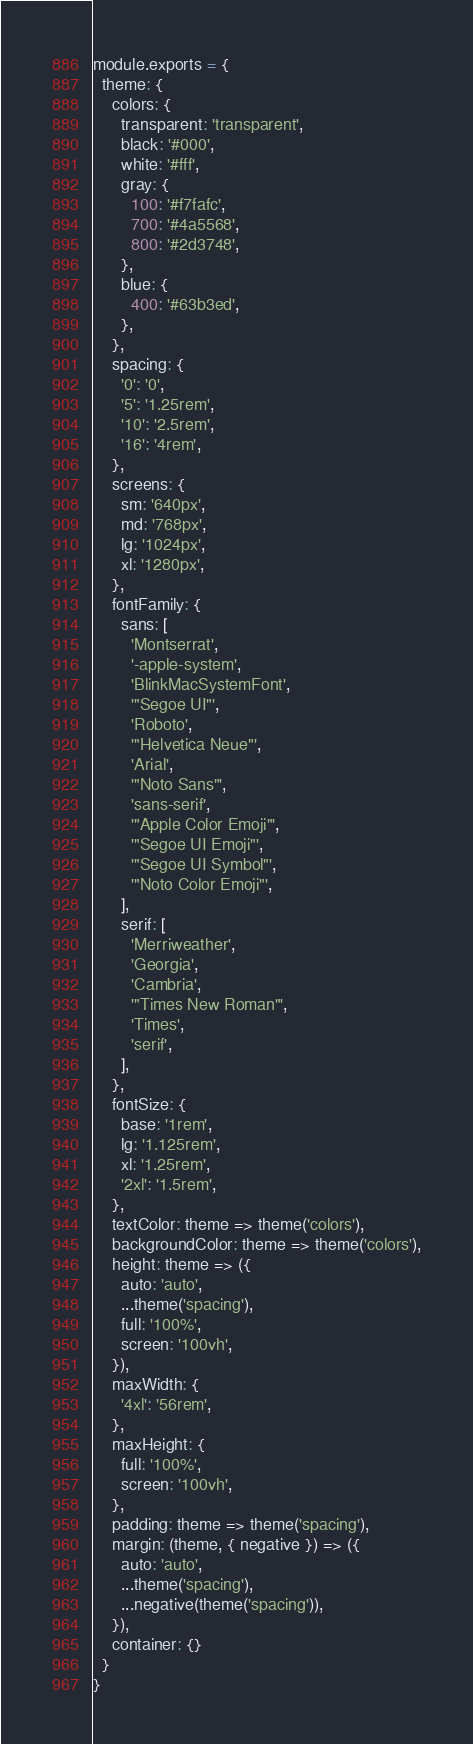Convert code to text. <code><loc_0><loc_0><loc_500><loc_500><_JavaScript_>module.exports = {
  theme: {
    colors: {
      transparent: 'transparent',
      black: '#000',
      white: '#fff',
      gray: {
        100: '#f7fafc',
        700: '#4a5568',
        800: '#2d3748',
      },
      blue: {
        400: '#63b3ed',
      },
    },
    spacing: {
      '0': '0',
      '5': '1.25rem',
      '10': '2.5rem',
      '16': '4rem',
    },
    screens: {
      sm: '640px',
      md: '768px',
      lg: '1024px',
      xl: '1280px',
    },
    fontFamily: {
      sans: [
        'Montserrat',
        '-apple-system',
        'BlinkMacSystemFont',
        '"Segoe UI"',
        'Roboto',
        '"Helvetica Neue"',
        'Arial',
        '"Noto Sans"',
        'sans-serif',
        '"Apple Color Emoji"',
        '"Segoe UI Emoji"',
        '"Segoe UI Symbol"',
        '"Noto Color Emoji"',
      ],
      serif: [
        'Merriweather',
        'Georgia',
        'Cambria',
        '"Times New Roman"',
        'Times',
        'serif',
      ],
    },
    fontSize: {
      base: '1rem',
      lg: '1.125rem',
      xl: '1.25rem',
      '2xl': '1.5rem',
    },
    textColor: theme => theme('colors'),
    backgroundColor: theme => theme('colors'),
    height: theme => ({
      auto: 'auto',
      ...theme('spacing'),
      full: '100%',
      screen: '100vh',
    }),
    maxWidth: {
      '4xl': '56rem',
    },
    maxHeight: {
      full: '100%',
      screen: '100vh',
    },
    padding: theme => theme('spacing'),
    margin: (theme, { negative }) => ({
      auto: 'auto',
      ...theme('spacing'),
      ...negative(theme('spacing')),
    }),
    container: {}
  }
}
</code> 